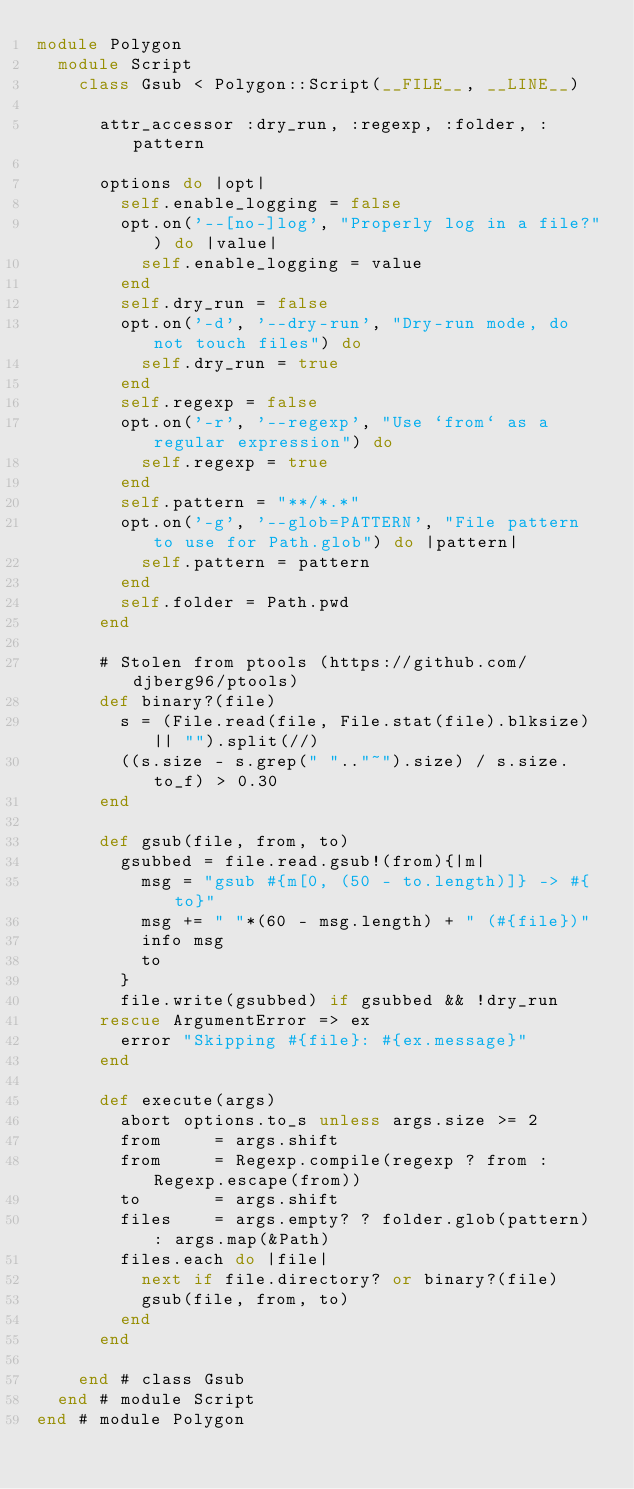<code> <loc_0><loc_0><loc_500><loc_500><_Ruby_>module Polygon
  module Script
    class Gsub < Polygon::Script(__FILE__, __LINE__)

      attr_accessor :dry_run, :regexp, :folder, :pattern

      options do |opt|
        self.enable_logging = false
        opt.on('--[no-]log', "Properly log in a file?") do |value|
          self.enable_logging = value
        end
        self.dry_run = false
        opt.on('-d', '--dry-run', "Dry-run mode, do not touch files") do
          self.dry_run = true
        end
        self.regexp = false
        opt.on('-r', '--regexp', "Use `from` as a regular expression") do
          self.regexp = true
        end
        self.pattern = "**/*.*"
        opt.on('-g', '--glob=PATTERN', "File pattern to use for Path.glob") do |pattern|
          self.pattern = pattern
        end
        self.folder = Path.pwd
      end

      # Stolen from ptools (https://github.com/djberg96/ptools)
      def binary?(file)
        s = (File.read(file, File.stat(file).blksize) || "").split(//)
        ((s.size - s.grep(" ".."~").size) / s.size.to_f) > 0.30
      end

      def gsub(file, from, to)
        gsubbed = file.read.gsub!(from){|m| 
          msg = "gsub #{m[0, (50 - to.length)]} -> #{to}"
          msg += " "*(60 - msg.length) + " (#{file})" 
          info msg 
          to
        }
        file.write(gsubbed) if gsubbed && !dry_run
      rescue ArgumentError => ex
        error "Skipping #{file}: #{ex.message}"
      end

      def execute(args)
        abort options.to_s unless args.size >= 2
        from     = args.shift
        from     = Regexp.compile(regexp ? from : Regexp.escape(from))
        to       = args.shift
        files    = args.empty? ? folder.glob(pattern) : args.map(&Path)
        files.each do |file|
          next if file.directory? or binary?(file)
          gsub(file, from, to)
        end
      end

    end # class Gsub
  end # module Script
end # module Polygon</code> 